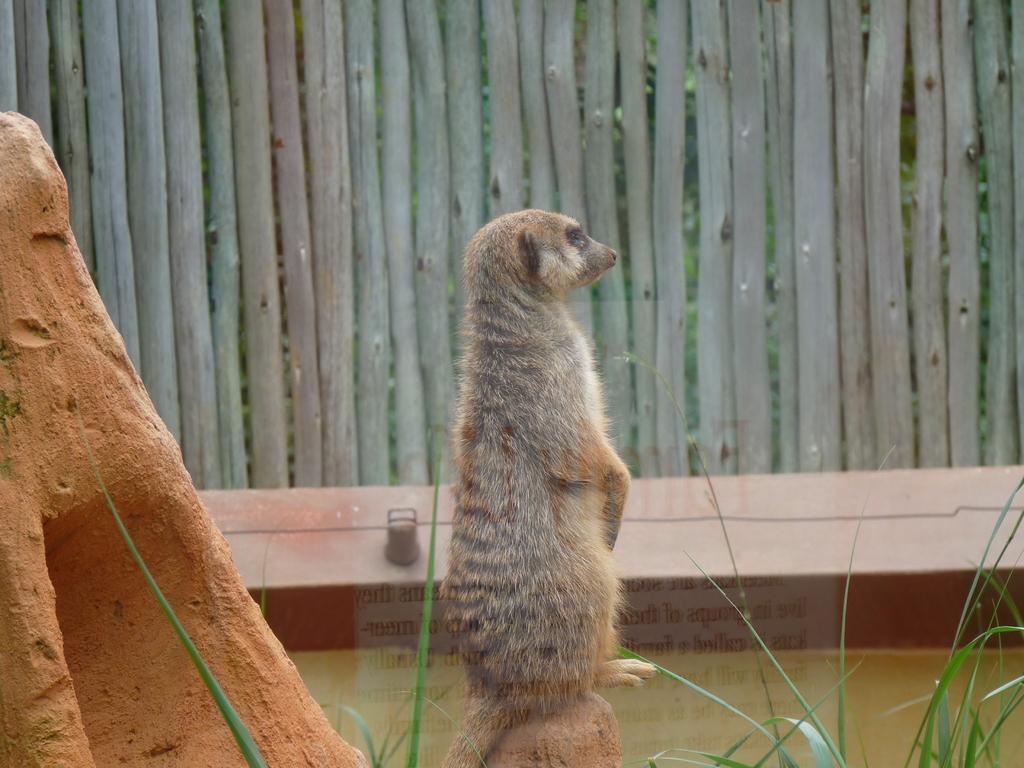Describe this image in one or two sentences. In this image I see an animal which is of grey and white in color and I see the brown color thing over here and I see the green grass. In the background I see the wooden fencing. 